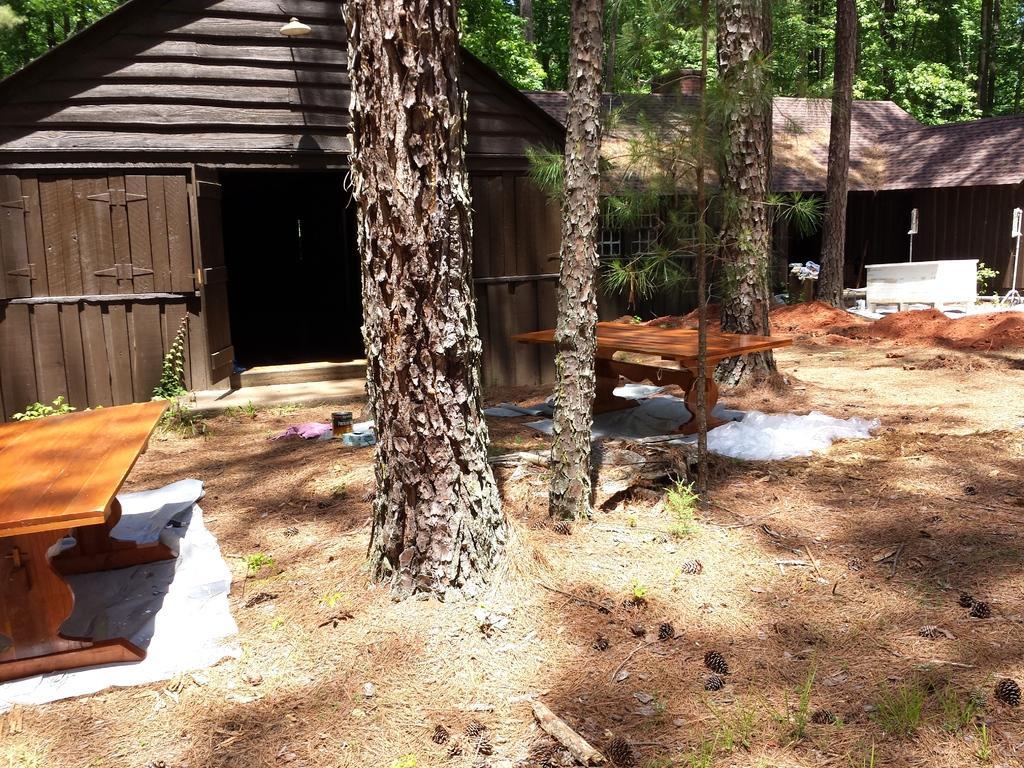In one or two sentences, can you explain what this image depicts? In this image we can see a house and many trees. There is a two tables in the image. 